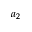Convert formula to latex. <formula><loc_0><loc_0><loc_500><loc_500>a _ { 2 }</formula> 